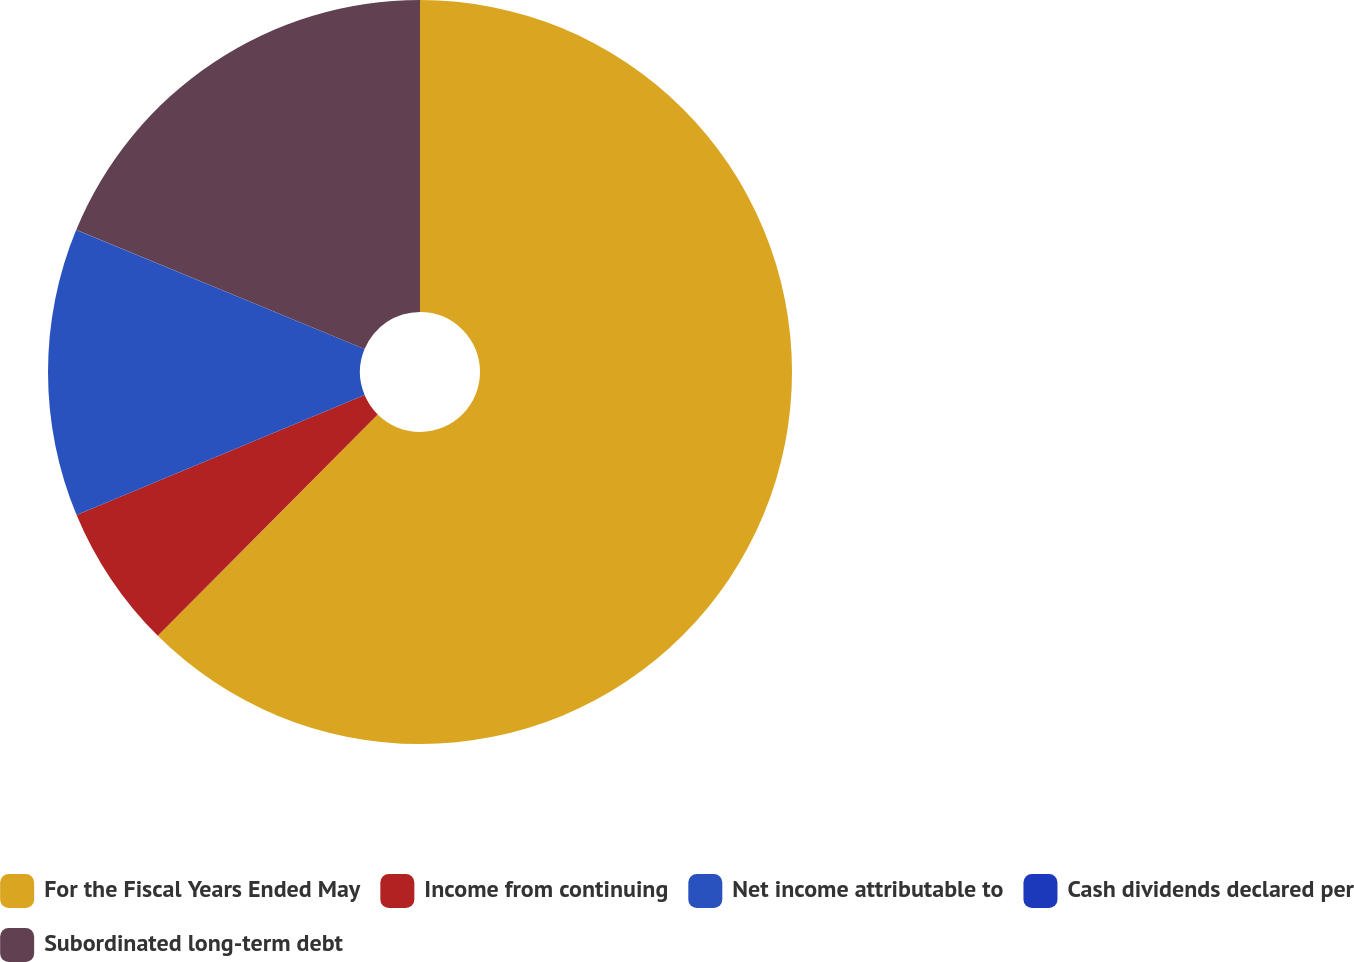Convert chart. <chart><loc_0><loc_0><loc_500><loc_500><pie_chart><fcel>For the Fiscal Years Ended May<fcel>Income from continuing<fcel>Net income attributable to<fcel>Cash dividends declared per<fcel>Subordinated long-term debt<nl><fcel>62.45%<fcel>6.27%<fcel>12.51%<fcel>0.02%<fcel>18.75%<nl></chart> 